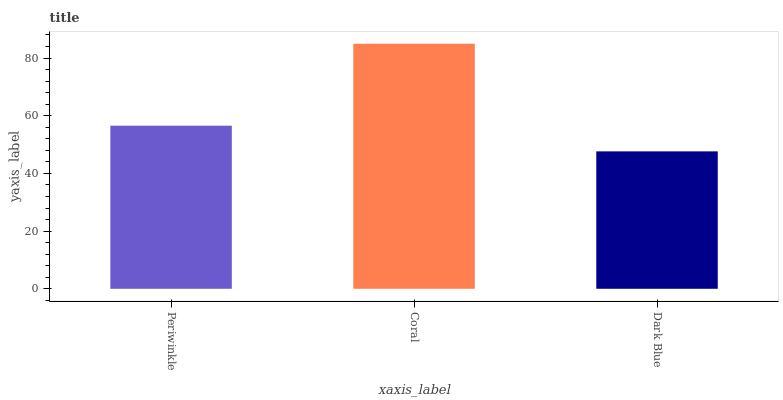Is Dark Blue the minimum?
Answer yes or no. Yes. Is Coral the maximum?
Answer yes or no. Yes. Is Coral the minimum?
Answer yes or no. No. Is Dark Blue the maximum?
Answer yes or no. No. Is Coral greater than Dark Blue?
Answer yes or no. Yes. Is Dark Blue less than Coral?
Answer yes or no. Yes. Is Dark Blue greater than Coral?
Answer yes or no. No. Is Coral less than Dark Blue?
Answer yes or no. No. Is Periwinkle the high median?
Answer yes or no. Yes. Is Periwinkle the low median?
Answer yes or no. Yes. Is Coral the high median?
Answer yes or no. No. Is Coral the low median?
Answer yes or no. No. 